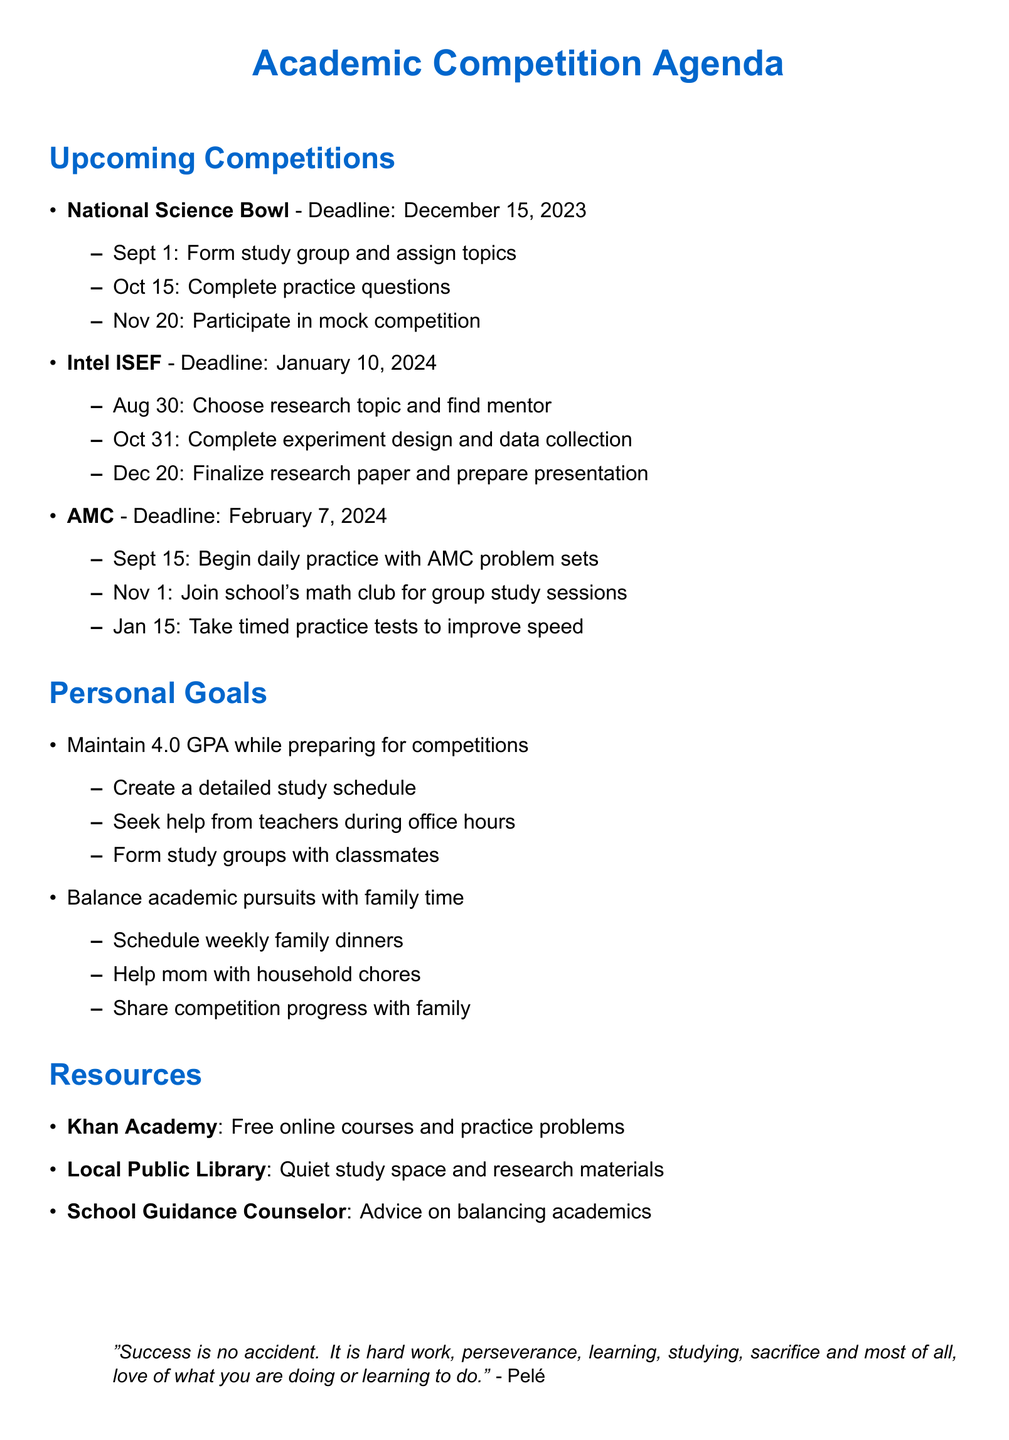What is the deadline for the National Science Bowl? The deadline is explicitly stated in the document as December 15, 2023.
Answer: December 15, 2023 What is the first milestone for the Intel International Science and Engineering Fair? The first milestone listed is to choose a research topic and find a mentor, which is due on August 30, 2023.
Answer: Choose research topic and find mentor How many competitions are listed in the document? The document lists three academic competitions: National Science Bowl, Intel ISEF, and AMC.
Answer: Three What actions are recommended to maintain a 4.0 GPA? The document specifies three actions: create a detailed study schedule, seek help from teachers during office hours, and form study groups with classmates.
Answer: Create a detailed study schedule Which resource provides a quiet study space? The document references the Local Public Library as a resource providing a quiet study space and access to research materials.
Answer: Local Public Library What is the preparation date for taking timed practice tests for the AMC? The document specifies that the preparation date for taking timed practice tests is January 15, 2024.
Answer: January 15, 2024 Who is quoted in the motivational quote at the bottom of the document? The motivational quote is attributed to Pelé.
Answer: Pelé What is the deadline for the AMC competition? The deadline for the AMC competition is explicitly stated as February 7, 2024.
Answer: February 7, 2024 Which online resource is mentioned for free courses and practice problems? The document mentions Khan Academy as the online resource for free courses and practice problems.
Answer: Khan Academy 